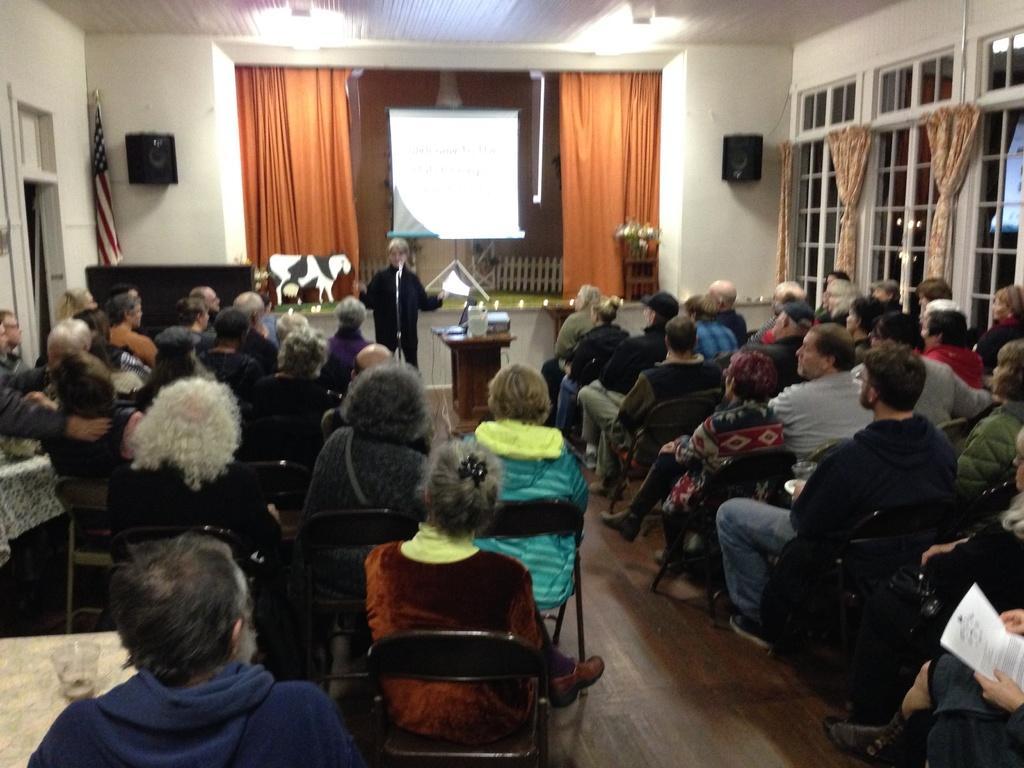Describe this image in one or two sentences. In this picture we can see a group of people sitting on chairs, paper, glass and in front of them we can see a person standing on the floor, mic, screen, curtains, speakers, flag, windows, walls and some objects. 